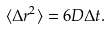<formula> <loc_0><loc_0><loc_500><loc_500>\langle \Delta r ^ { 2 } \rangle = 6 D \Delta t .</formula> 